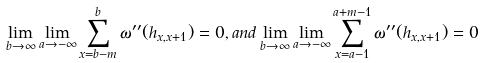Convert formula to latex. <formula><loc_0><loc_0><loc_500><loc_500>\lim _ { b \rightarrow \infty } \lim _ { a \rightarrow - \infty } \sum _ { x = b - m } ^ { b } \omega ^ { \prime \prime } ( h _ { x , x + 1 } ) = 0 , a n d \lim _ { b \rightarrow \infty } \lim _ { a \rightarrow - \infty } \sum _ { x = a - 1 } ^ { a + m - 1 } \omega ^ { \prime \prime } ( h _ { x , x + 1 } ) = 0</formula> 